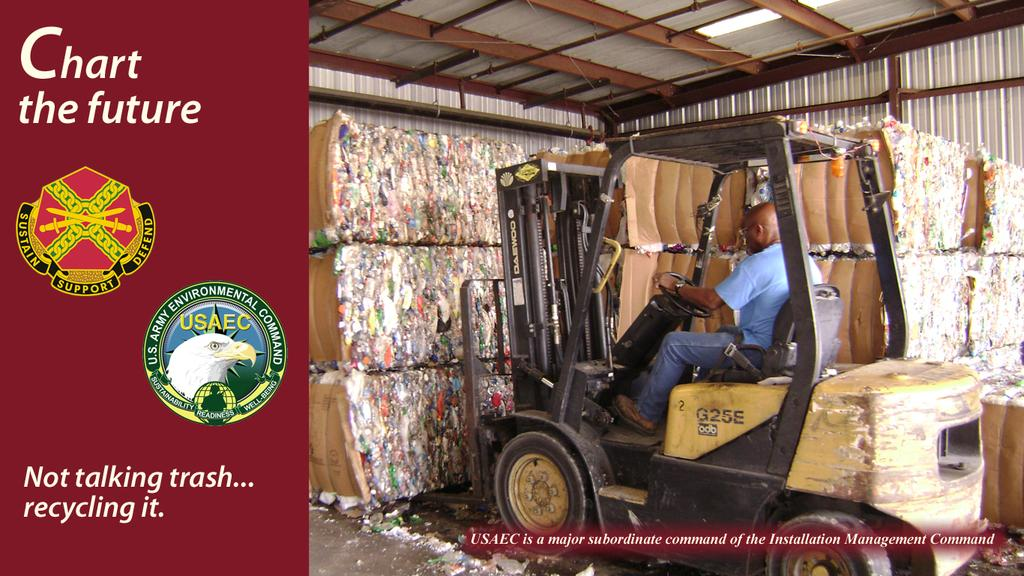What is the person in the image doing? There is a person sitting in a vehicle in the image. What can be seen in the background of the image? There is waste visible in the background. Where is the text located in the image? The text is on the left side of the image. What is visible at the top of the image? There is a roof visible at the top of the image. What type of shoe can be seen in the image? There is no shoe present in the image. Is the person in the image wearing a winter coat? The image does not provide information about the person's clothing, so it cannot be determined if they are wearing a winter coat. 